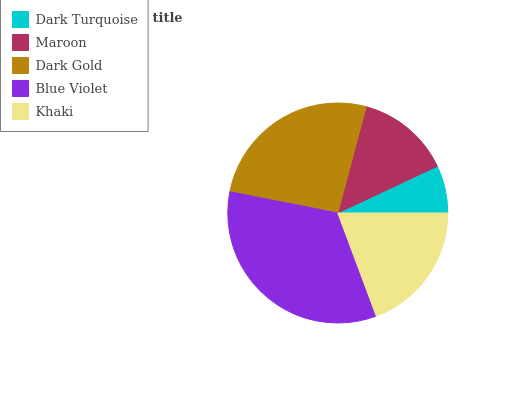Is Dark Turquoise the minimum?
Answer yes or no. Yes. Is Blue Violet the maximum?
Answer yes or no. Yes. Is Maroon the minimum?
Answer yes or no. No. Is Maroon the maximum?
Answer yes or no. No. Is Maroon greater than Dark Turquoise?
Answer yes or no. Yes. Is Dark Turquoise less than Maroon?
Answer yes or no. Yes. Is Dark Turquoise greater than Maroon?
Answer yes or no. No. Is Maroon less than Dark Turquoise?
Answer yes or no. No. Is Khaki the high median?
Answer yes or no. Yes. Is Khaki the low median?
Answer yes or no. Yes. Is Maroon the high median?
Answer yes or no. No. Is Maroon the low median?
Answer yes or no. No. 